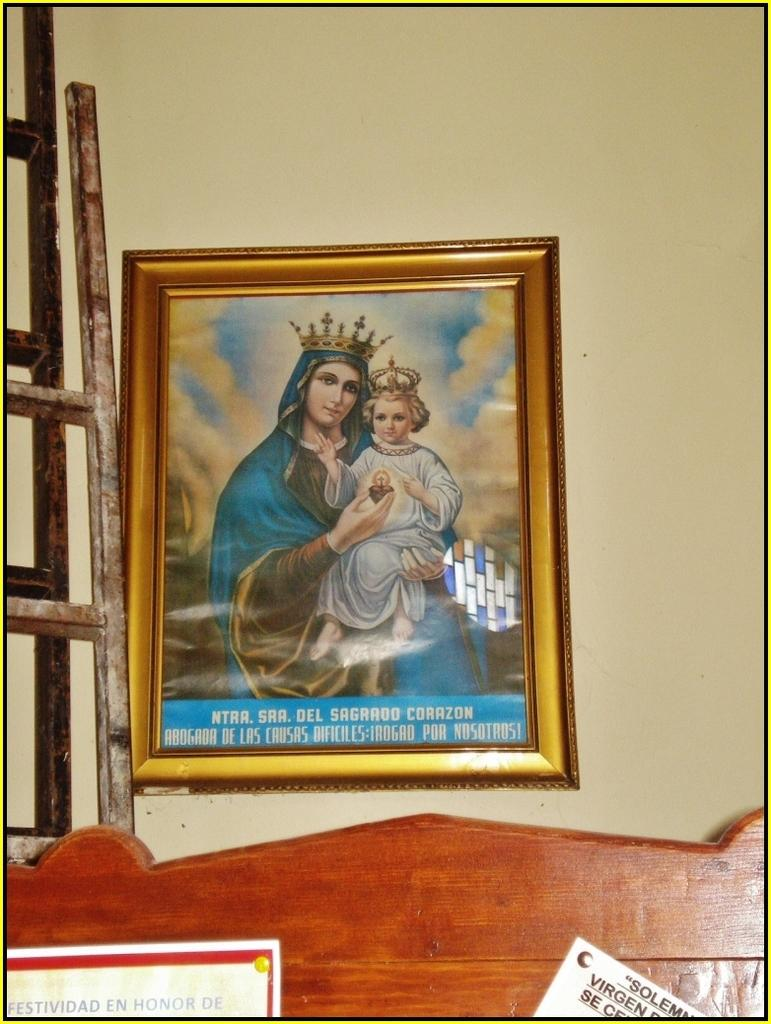<image>
Share a concise interpretation of the image provided. A painting on a wall of a woman and klittle girl wearing a crown that says NTR. SHA. DEL SAGRADO CORAZON. 